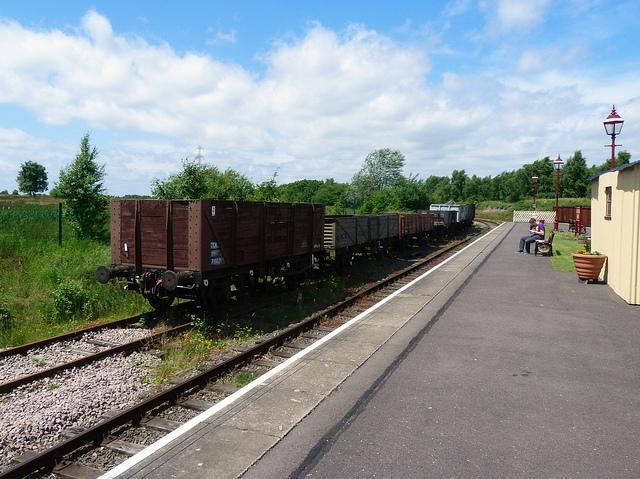How many people can be seen?
Give a very brief answer. 2. How many people are waiting for a train?
Give a very brief answer. 2. How many people on motorcycles are facing this way?
Give a very brief answer. 0. 